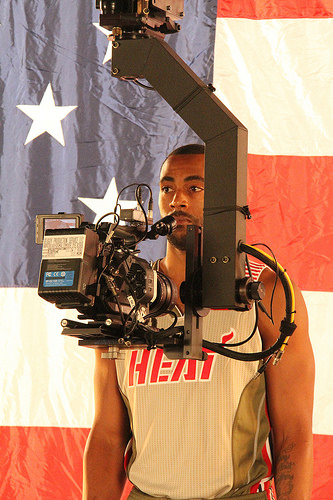<image>
Is there a man behind the camera? Yes. From this viewpoint, the man is positioned behind the camera, with the camera partially or fully occluding the man. 